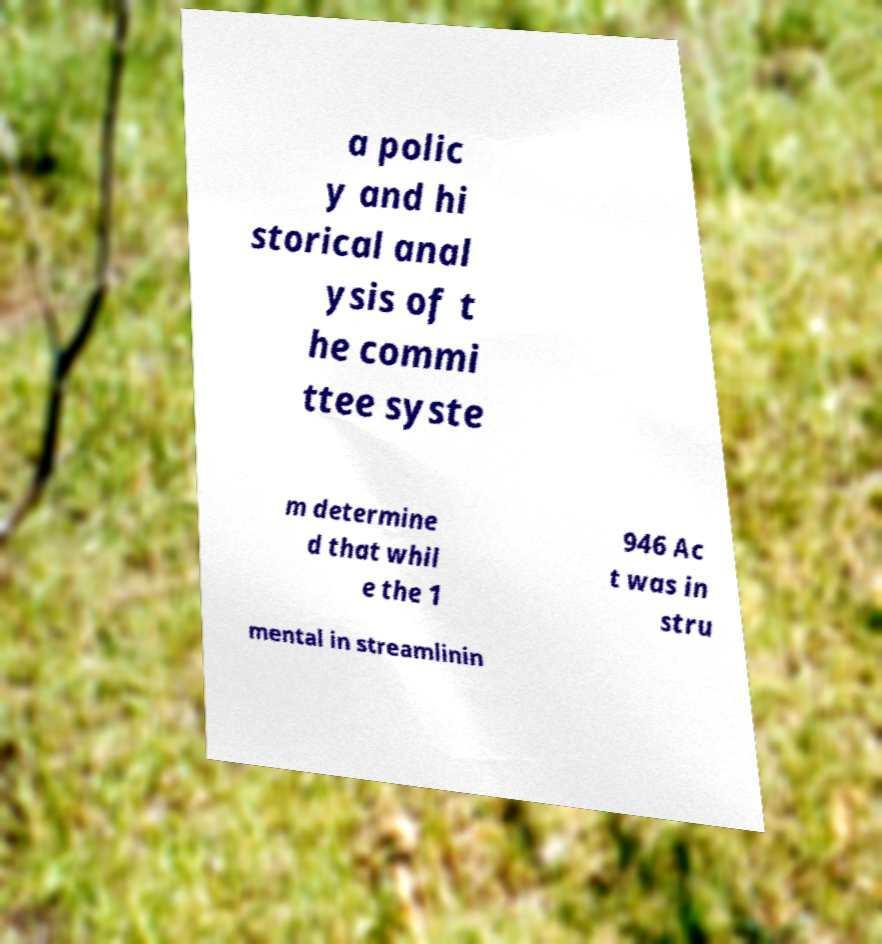I need the written content from this picture converted into text. Can you do that? a polic y and hi storical anal ysis of t he commi ttee syste m determine d that whil e the 1 946 Ac t was in stru mental in streamlinin 